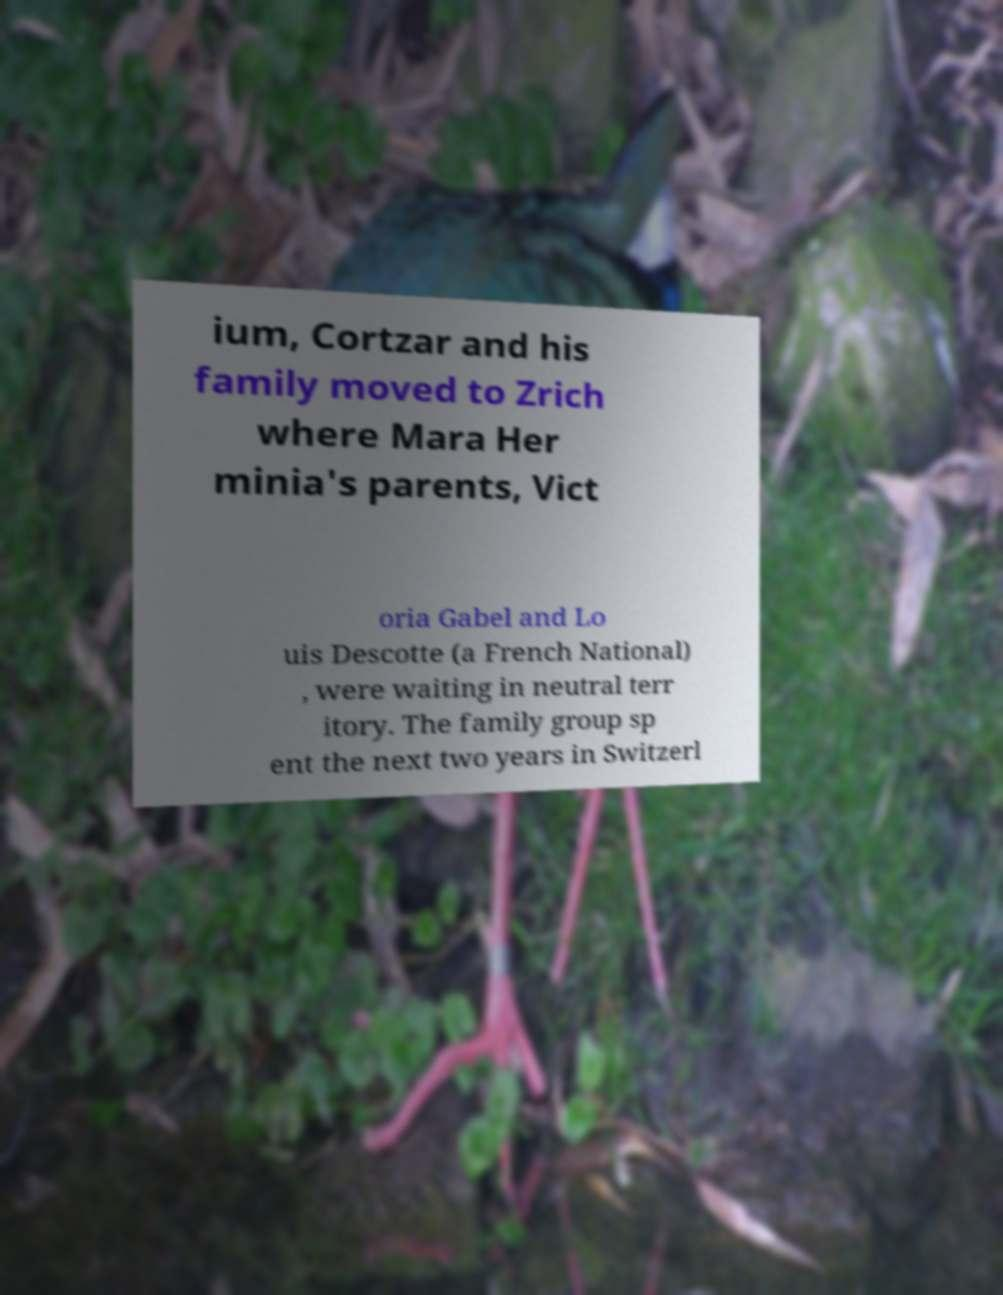Could you assist in decoding the text presented in this image and type it out clearly? ium, Cortzar and his family moved to Zrich where Mara Her minia's parents, Vict oria Gabel and Lo uis Descotte (a French National) , were waiting in neutral terr itory. The family group sp ent the next two years in Switzerl 